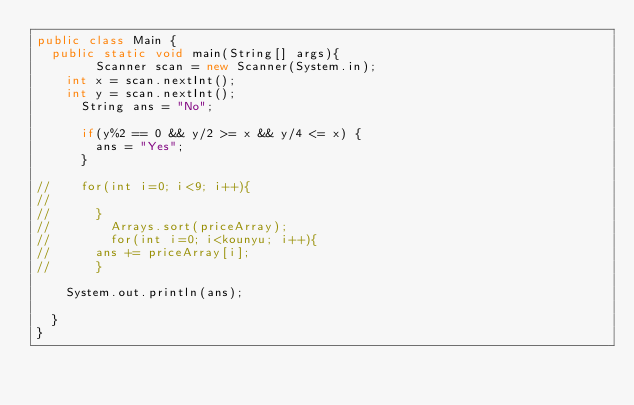Convert code to text. <code><loc_0><loc_0><loc_500><loc_500><_Java_>public class Main {
	public static void main(String[] args){
      	Scanner scan = new Scanner(System.in);
		int x = scan.nextInt();
 		int y = scan.nextInt();
      String ans = "No";
      
      if(y%2 == 0 && y/2 >= x && y/4 <= x) {
    	  ans = "Yes";
      }

//		for(int i=0; i<9; i++){
//			
//			}
//        Arrays.sort(priceArray);
//      	for(int i=0; i<kounyu; i++){
//			ans += priceArray[i];
//			}

		System.out.println(ans);   
 
	}
}</code> 